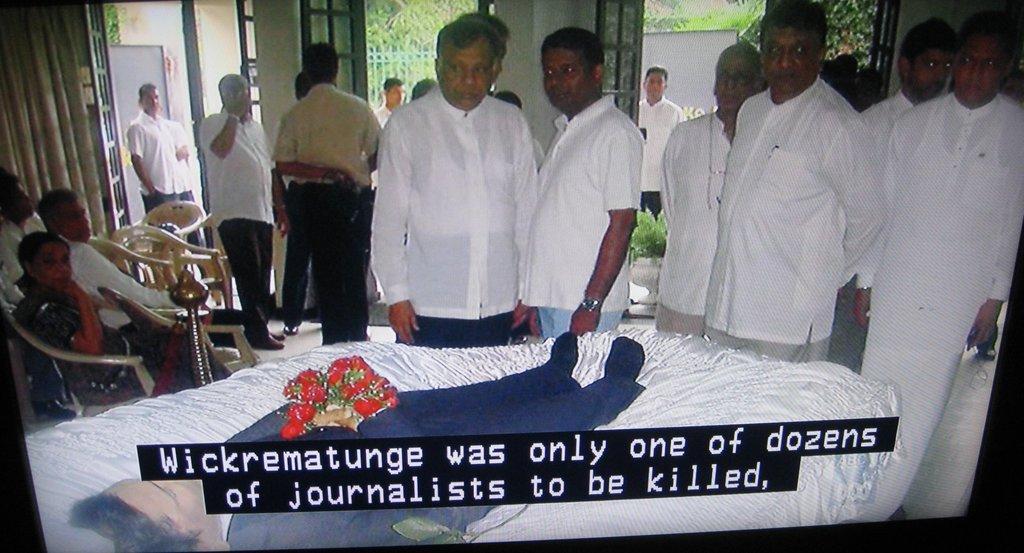Describe this image in one or two sentences. This is the screen. I can see group of people standing and three people sitting on the chairs. Here is the curtain hanging. These are the doors. I can see the man sleeping on the bed. This looks like a flower bouquet. I can see the trees through the door. This is the subtitle. 